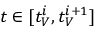<formula> <loc_0><loc_0><loc_500><loc_500>t \in [ t _ { V } ^ { i } , t _ { V } ^ { i + 1 } ]</formula> 